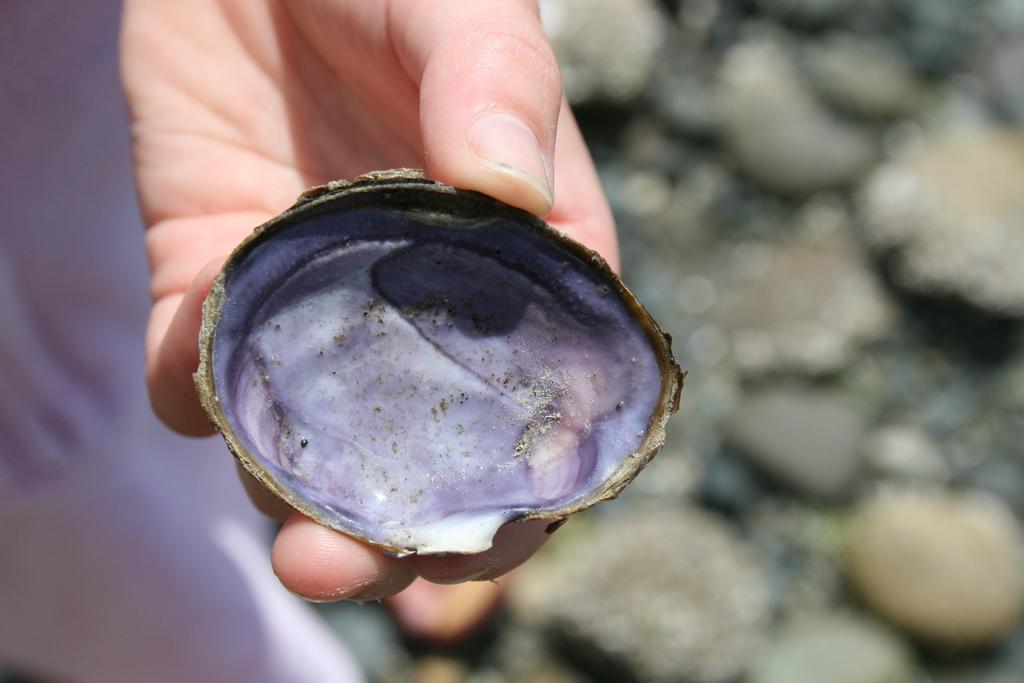Could you give a brief overview of what you see in this image? In this picture there is a man holding the shell. At the bottom there are stones and the image is blurry. 